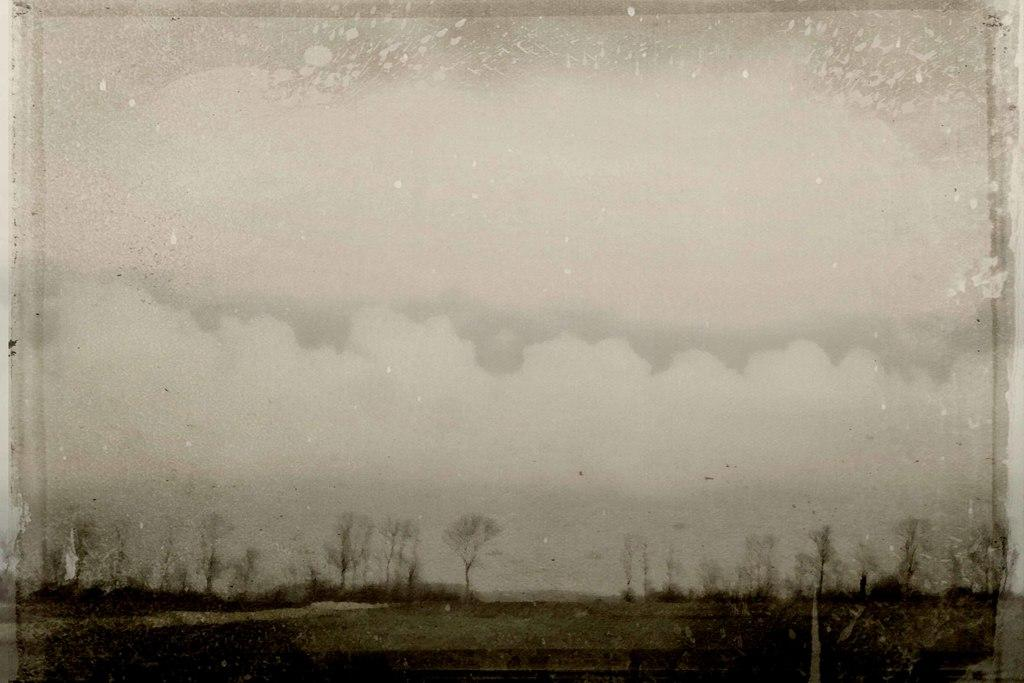What is the color scheme of the image? The image is black and white. What type of natural elements can be seen in the image? There are trees in the image. What part of the natural environment is visible in the image? The sky is visible in the image. What type of lunchroom is depicted in the image? There is no lunchroom present in the image; it is a black and white image with trees and a visible sky. What idea can be derived from the image about the mind? The image does not provide any information about the mind or any ideas related to it. 